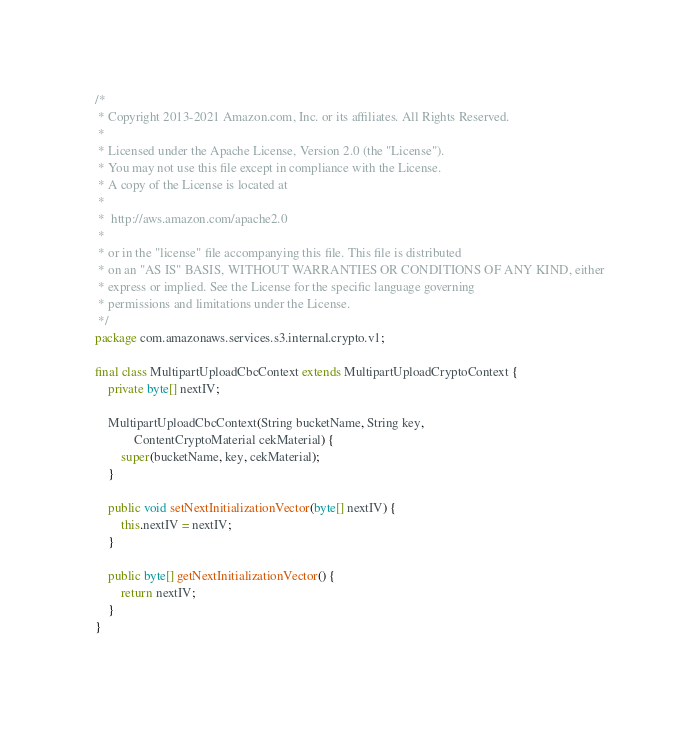<code> <loc_0><loc_0><loc_500><loc_500><_Java_>/*
 * Copyright 2013-2021 Amazon.com, Inc. or its affiliates. All Rights Reserved.
 *
 * Licensed under the Apache License, Version 2.0 (the "License").
 * You may not use this file except in compliance with the License.
 * A copy of the License is located at
 *
 *  http://aws.amazon.com/apache2.0
 *
 * or in the "license" file accompanying this file. This file is distributed
 * on an "AS IS" BASIS, WITHOUT WARRANTIES OR CONDITIONS OF ANY KIND, either
 * express or implied. See the License for the specific language governing
 * permissions and limitations under the License.
 */
package com.amazonaws.services.s3.internal.crypto.v1;

final class MultipartUploadCbcContext extends MultipartUploadCryptoContext {
    private byte[] nextIV;

    MultipartUploadCbcContext(String bucketName, String key,
            ContentCryptoMaterial cekMaterial) {
        super(bucketName, key, cekMaterial);
    }

    public void setNextInitializationVector(byte[] nextIV) {
        this.nextIV = nextIV;
    }

    public byte[] getNextInitializationVector() {
        return nextIV;
    }
}
</code> 